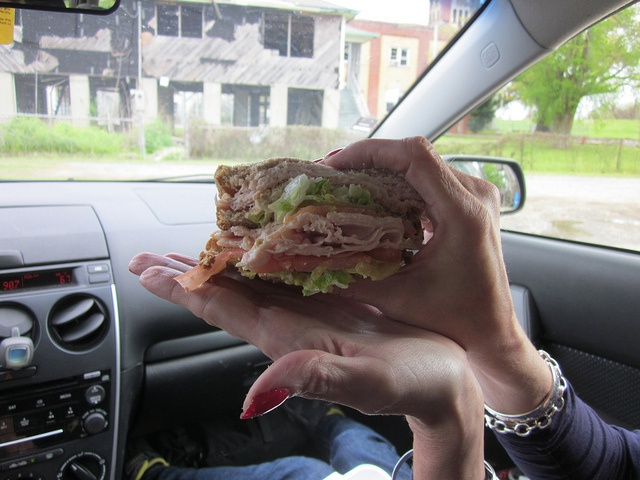Describe the objects in this image and their specific colors. I can see car in brown, lightgray, black, darkgray, and gray tones, people in brown, maroon, gray, and black tones, sandwich in brown, maroon, gray, and black tones, and clock in brown, black, maroon, and gray tones in this image. 